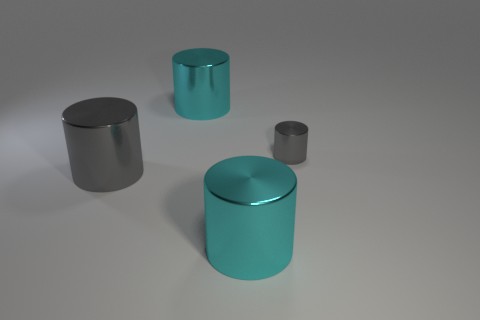Add 4 cyan things. How many objects exist? 8 Add 2 large purple matte cylinders. How many large purple matte cylinders exist? 2 Subtract 0 yellow balls. How many objects are left? 4 Subtract all tiny cylinders. Subtract all small rubber blocks. How many objects are left? 3 Add 4 metallic cylinders. How many metallic cylinders are left? 8 